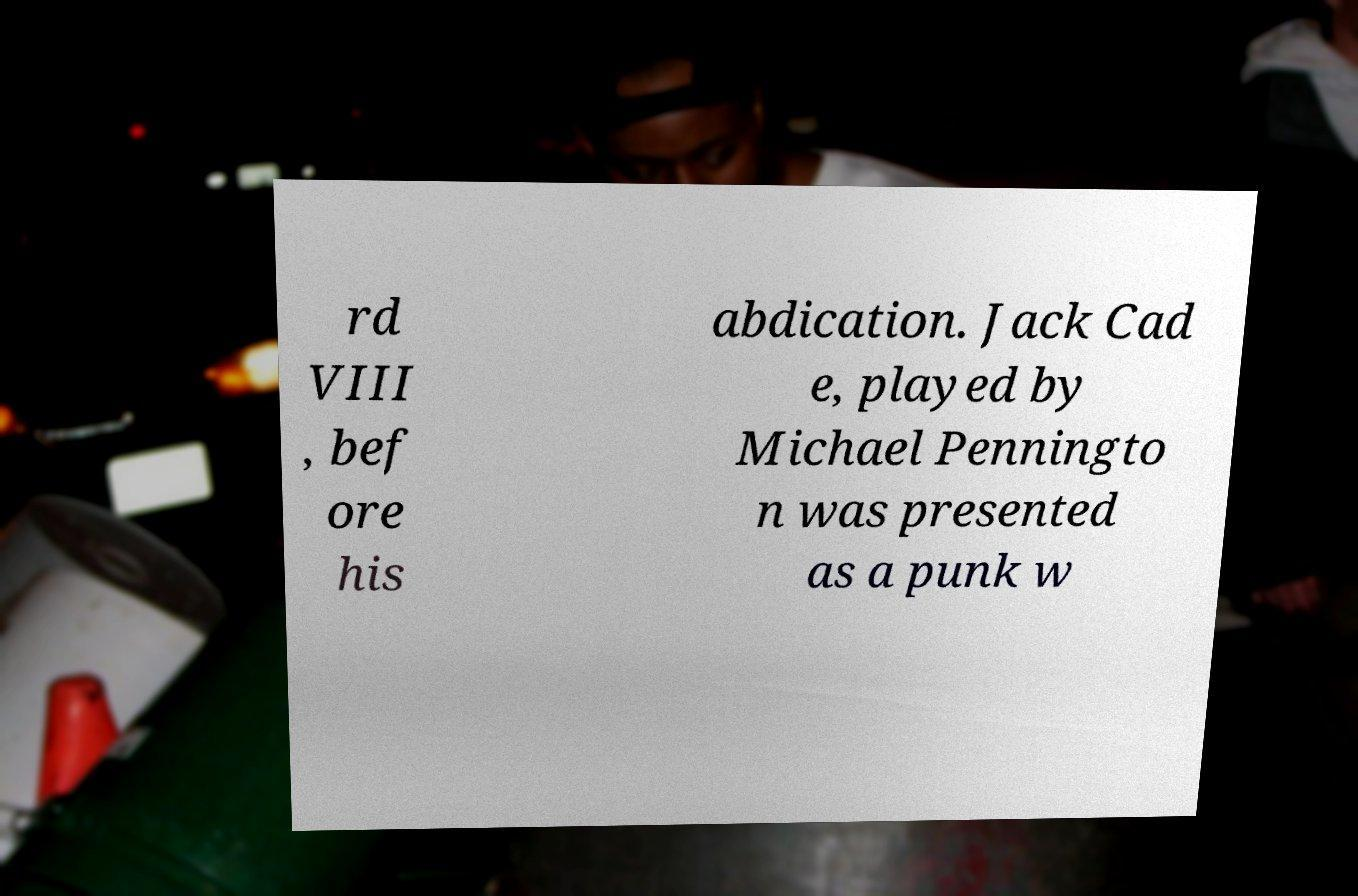I need the written content from this picture converted into text. Can you do that? rd VIII , bef ore his abdication. Jack Cad e, played by Michael Penningto n was presented as a punk w 